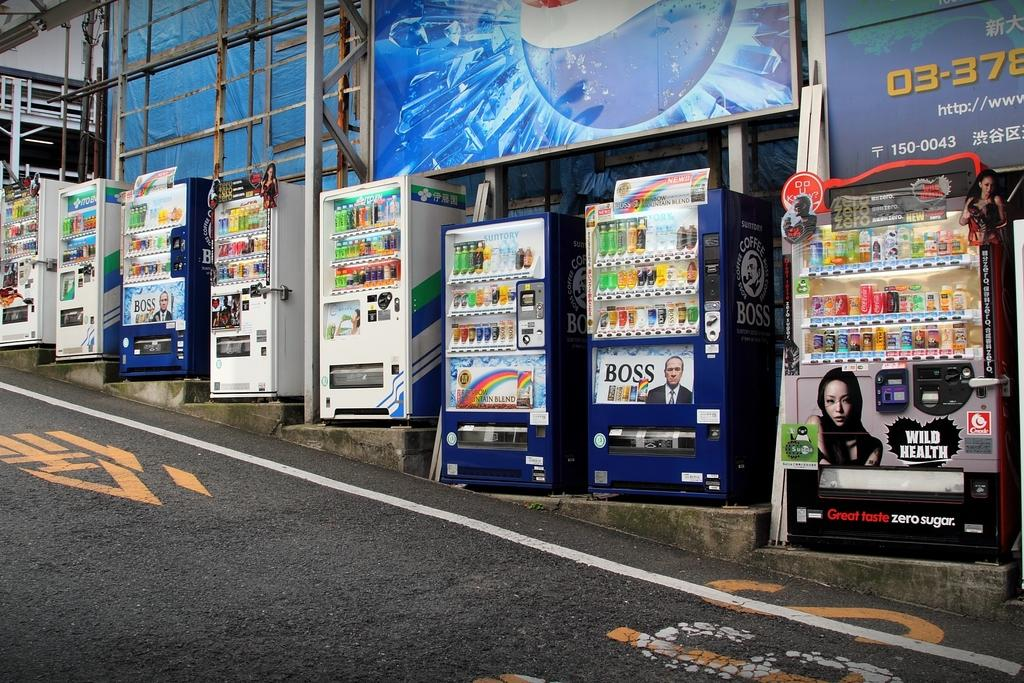<image>
Summarize the visual content of the image. Three vending machines on a street with one saying Wild Health. 